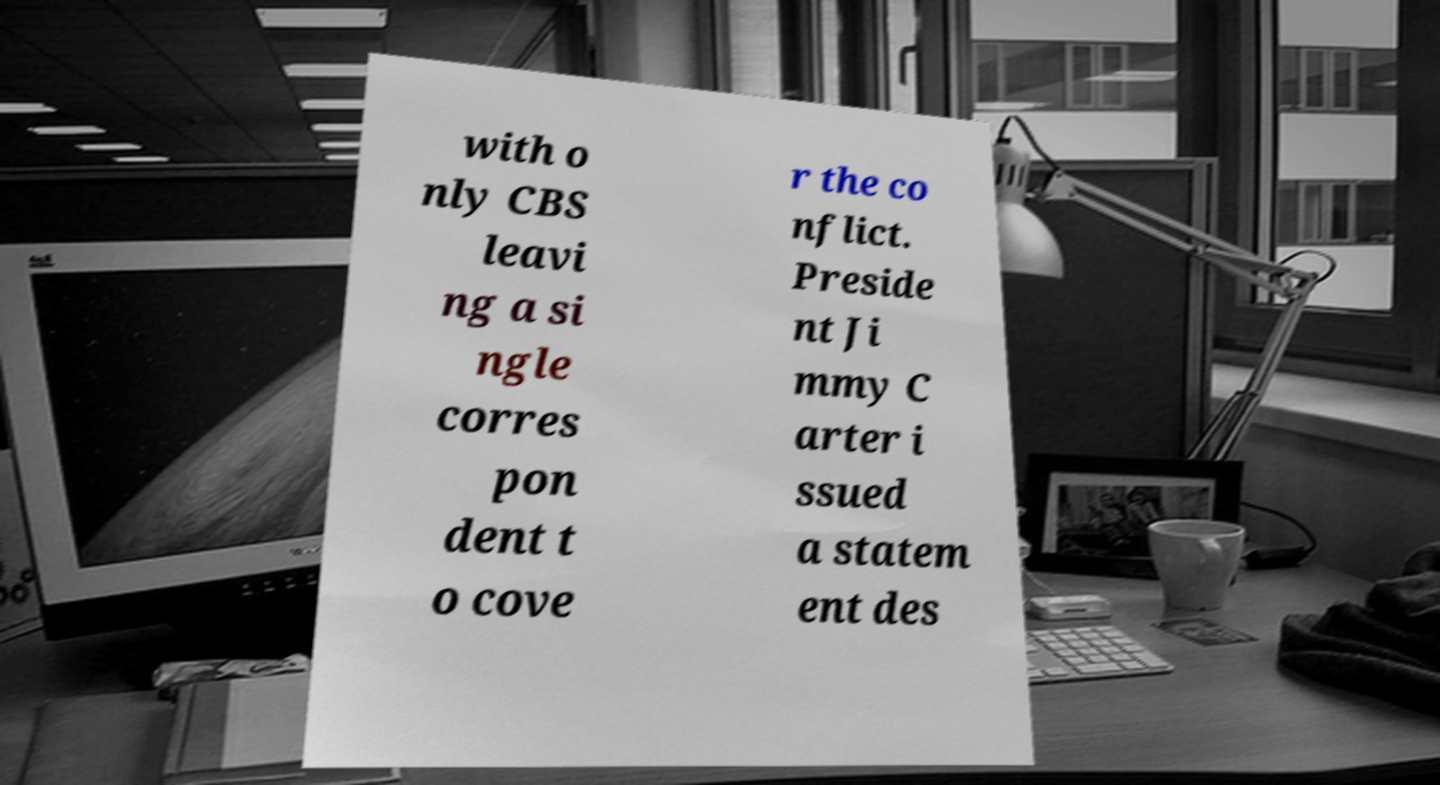Can you read and provide the text displayed in the image?This photo seems to have some interesting text. Can you extract and type it out for me? with o nly CBS leavi ng a si ngle corres pon dent t o cove r the co nflict. Preside nt Ji mmy C arter i ssued a statem ent des 